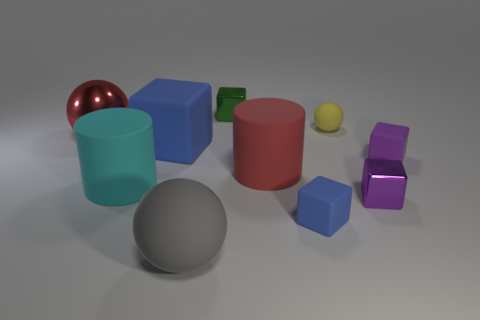What number of things are small rubber balls or small objects right of the yellow sphere?
Your answer should be very brief. 3. The large cylinder that is to the right of the big gray rubber thing that is in front of the tiny cube behind the small yellow thing is what color?
Offer a terse response. Red. There is a big object that is the same shape as the small green object; what is it made of?
Ensure brevity in your answer.  Rubber. The large metallic thing has what color?
Your answer should be compact. Red. What number of matte objects are purple blocks or yellow spheres?
Keep it short and to the point. 2. Is there a big cylinder to the right of the small cube that is behind the small purple thing behind the large red cylinder?
Ensure brevity in your answer.  Yes. What is the size of the yellow ball that is made of the same material as the big cyan cylinder?
Offer a very short reply. Small. Are there any tiny blue things to the left of the purple metal object?
Your answer should be very brief. Yes. There is a red thing that is on the left side of the gray thing; is there a purple cube that is to the right of it?
Your answer should be very brief. Yes. Do the rubber sphere that is in front of the red rubber thing and the red object on the right side of the big blue matte cube have the same size?
Keep it short and to the point. Yes. 